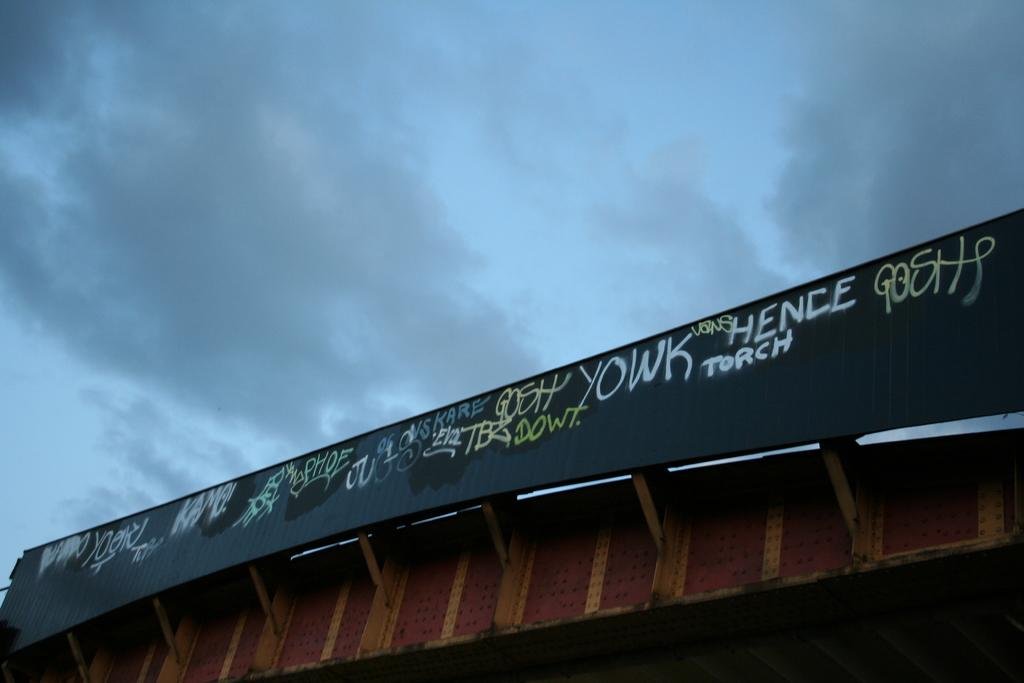<image>
Give a short and clear explanation of the subsequent image. the word yowk is on the side of a bridge 